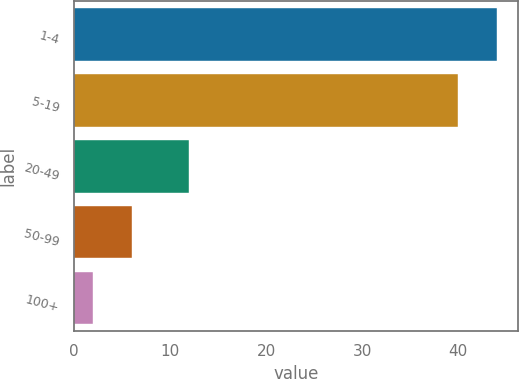<chart> <loc_0><loc_0><loc_500><loc_500><bar_chart><fcel>1-4<fcel>5-19<fcel>20-49<fcel>50-99<fcel>100+<nl><fcel>44<fcel>40<fcel>12<fcel>6<fcel>2<nl></chart> 